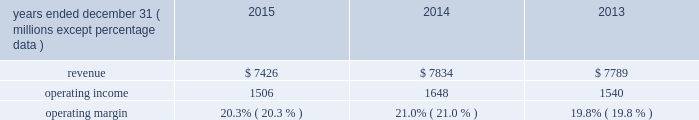( 2 ) in 2013 , our principal u.k subsidiary agreed with the trustees of one of the u.k .
Plans to contribute an average of $ 11 million per year to that pension plan for the next three years .
The trustees of the plan have certain rights to request that our u.k .
Subsidiary advance an amount equal to an actuarially determined winding-up deficit .
As of december 31 , 2015 , the estimated winding-up deficit was a3240 million ( $ 360 million at december 31 , 2015 exchange rates ) .
The trustees of the plan have accepted in practice the agreed-upon schedule of contributions detailed above and have not requested the winding-up deficit be paid .
( 3 ) purchase obligations are defined as agreements to purchase goods and services that are enforceable and legally binding on us , and that specifies all significant terms , including what is to be purchased , at what price and the approximate timing of the transaction .
Most of our purchase obligations are related to purchases of information technology services or other service contracts .
( 4 ) excludes $ 12 million of unfunded commitments related to an investment in a limited partnership due to our inability to reasonably estimate the period ( s ) when the limited partnership will request funding .
( 5 ) excludes $ 218 million of liabilities for uncertain tax positions due to our inability to reasonably estimate the period ( s ) when potential cash settlements will be made .
Financial condition at december 31 , 2015 , our net assets were $ 6.2 billion , representing total assets minus total liabilities , a decrease from $ 6.6 billion at december 31 , 2014 .
The decrease was due primarily to share repurchases of $ 1.6 billion , dividends of $ 323 million , and an increase in accumulated other comprehensive loss of $ 289 million related primarily to an increase in the post- retirement benefit obligation , partially offset by net income of $ 1.4 billion for the year ended december 31 , 2015 .
Working capital increased by $ 77 million from $ 809 million at december 31 , 2014 to $ 886 million at december 31 , 2015 .
Accumulated other comprehensive loss increased $ 289 million at december 31 , 2015 as compared to december 31 , 2014 , which was primarily driven by the following : 2022 negative net foreign currency translation adjustments of $ 436 million , which are attributable to the strengthening of the u.s .
Dollar against certain foreign currencies , 2022 a decrease of $ 155 million in net post-retirement benefit obligations , and 2022 net financial instrument losses of $ 8 million .
Review by segment general we serve clients through the following segments : 2022 risk solutions acts as an advisor and insurance and reinsurance broker , helping clients manage their risks , via consultation , as well as negotiation and placement of insurance risk with insurance carriers through our global distribution network .
2022 hr solutions partners with organizations to solve their most complex benefits , talent and related financial challenges , and improve business performance by designing , implementing , communicating and administering a wide range of human capital , retirement , investment management , health care , compensation and talent management strategies .
Risk solutions .
The demand for property and casualty insurance generally rises as the overall level of economic activity increases and generally falls as such activity decreases , affecting both the commissions and fees generated by our brokerage business .
The economic activity that impacts property and casualty insurance is described as exposure units , and is most closely correlated .
What was the percentage change in working capital in 2014? 
Computations: (77 / 809)
Answer: 0.09518. 